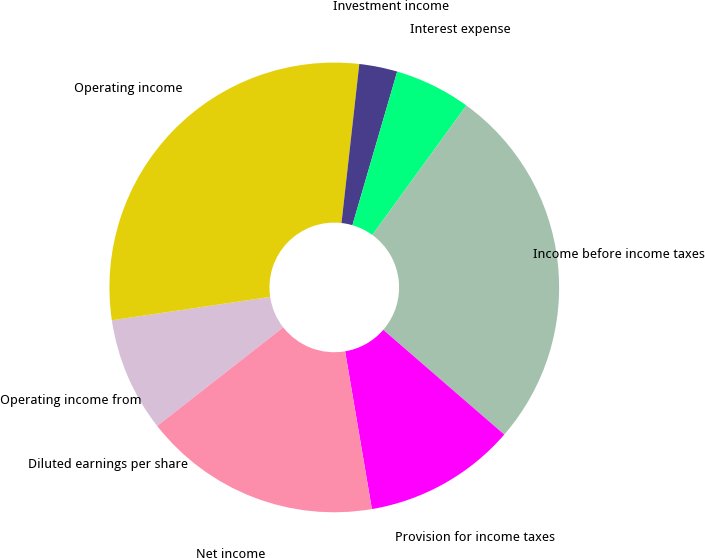<chart> <loc_0><loc_0><loc_500><loc_500><pie_chart><fcel>Operating income from<fcel>Operating income<fcel>Investment income<fcel>Interest expense<fcel>Income before income taxes<fcel>Provision for income taxes<fcel>Net income<fcel>Diluted earnings per share<nl><fcel>8.23%<fcel>29.11%<fcel>2.74%<fcel>5.48%<fcel>26.36%<fcel>10.97%<fcel>17.11%<fcel>0.0%<nl></chart> 